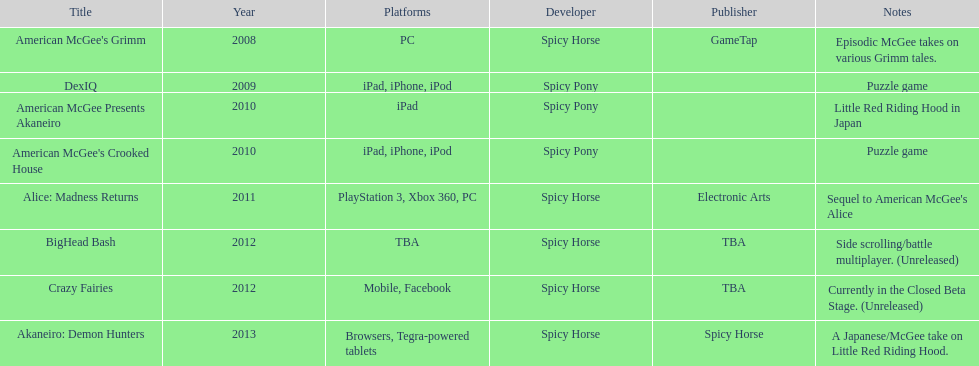What was the most recent game produced by spicy horse? Akaneiro: Demon Hunters. 